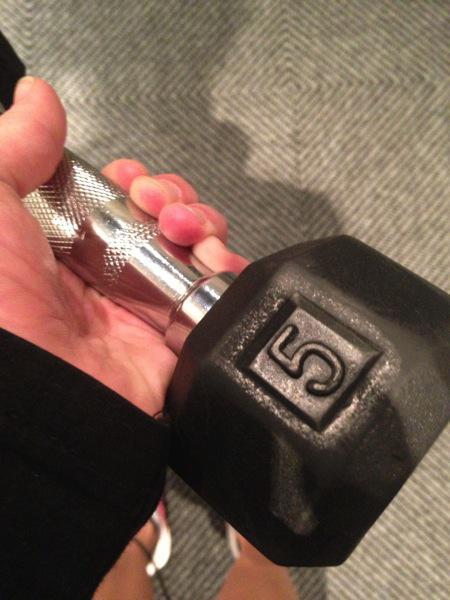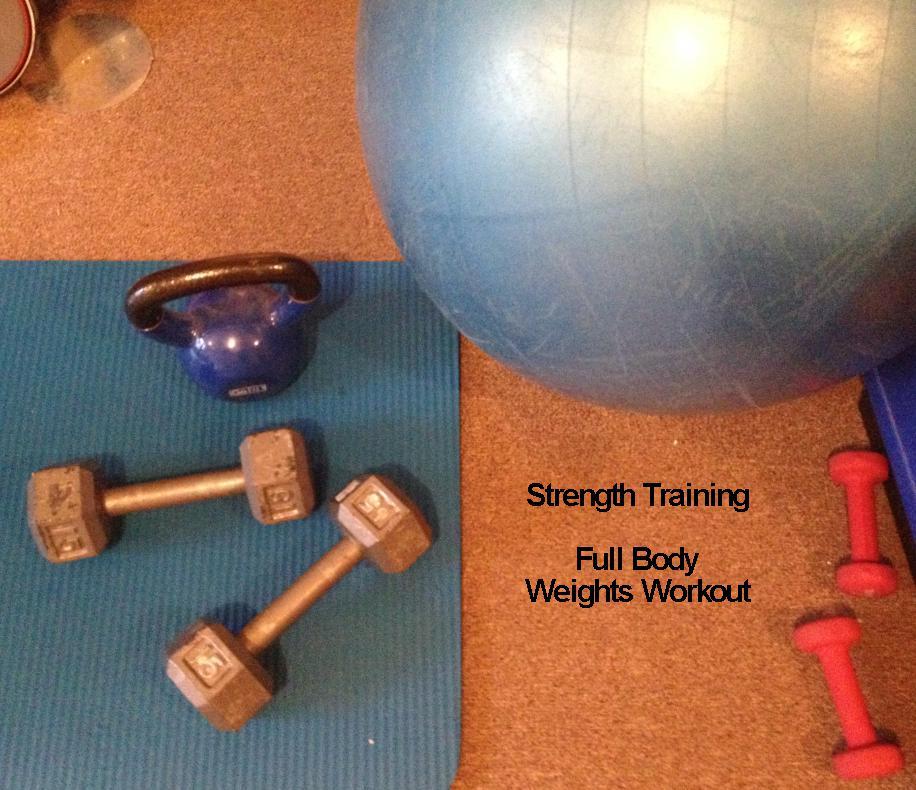The first image is the image on the left, the second image is the image on the right. Assess this claim about the two images: "One of the images shows an assembled dumbbell with additional plates next to it.". Correct or not? Answer yes or no. No. The first image is the image on the left, the second image is the image on the right. For the images displayed, is the sentence "there is a dumb bell laying on a wood floor next to 12 seperate circular flat weights" factually correct? Answer yes or no. No. 